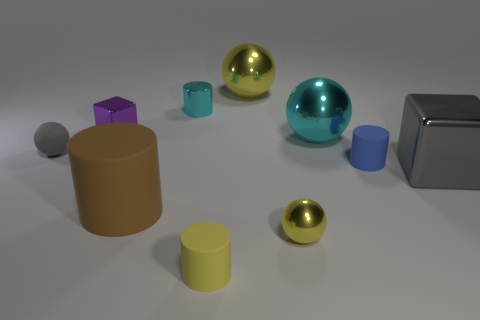Subtract 1 cylinders. How many cylinders are left? 3 Subtract all blue spheres. Subtract all blue blocks. How many spheres are left? 4 Subtract all spheres. How many objects are left? 6 Subtract 0 cyan blocks. How many objects are left? 10 Subtract all large gray matte cylinders. Subtract all tiny yellow rubber cylinders. How many objects are left? 9 Add 2 large blocks. How many large blocks are left? 3 Add 5 big brown cylinders. How many big brown cylinders exist? 6 